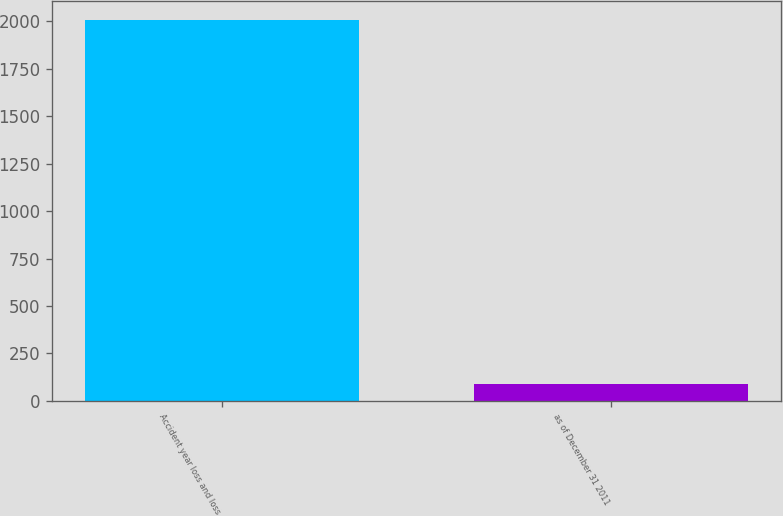Convert chart to OTSL. <chart><loc_0><loc_0><loc_500><loc_500><bar_chart><fcel>Accident year loss and loss<fcel>as of December 31 2011<nl><fcel>2009<fcel>89<nl></chart> 